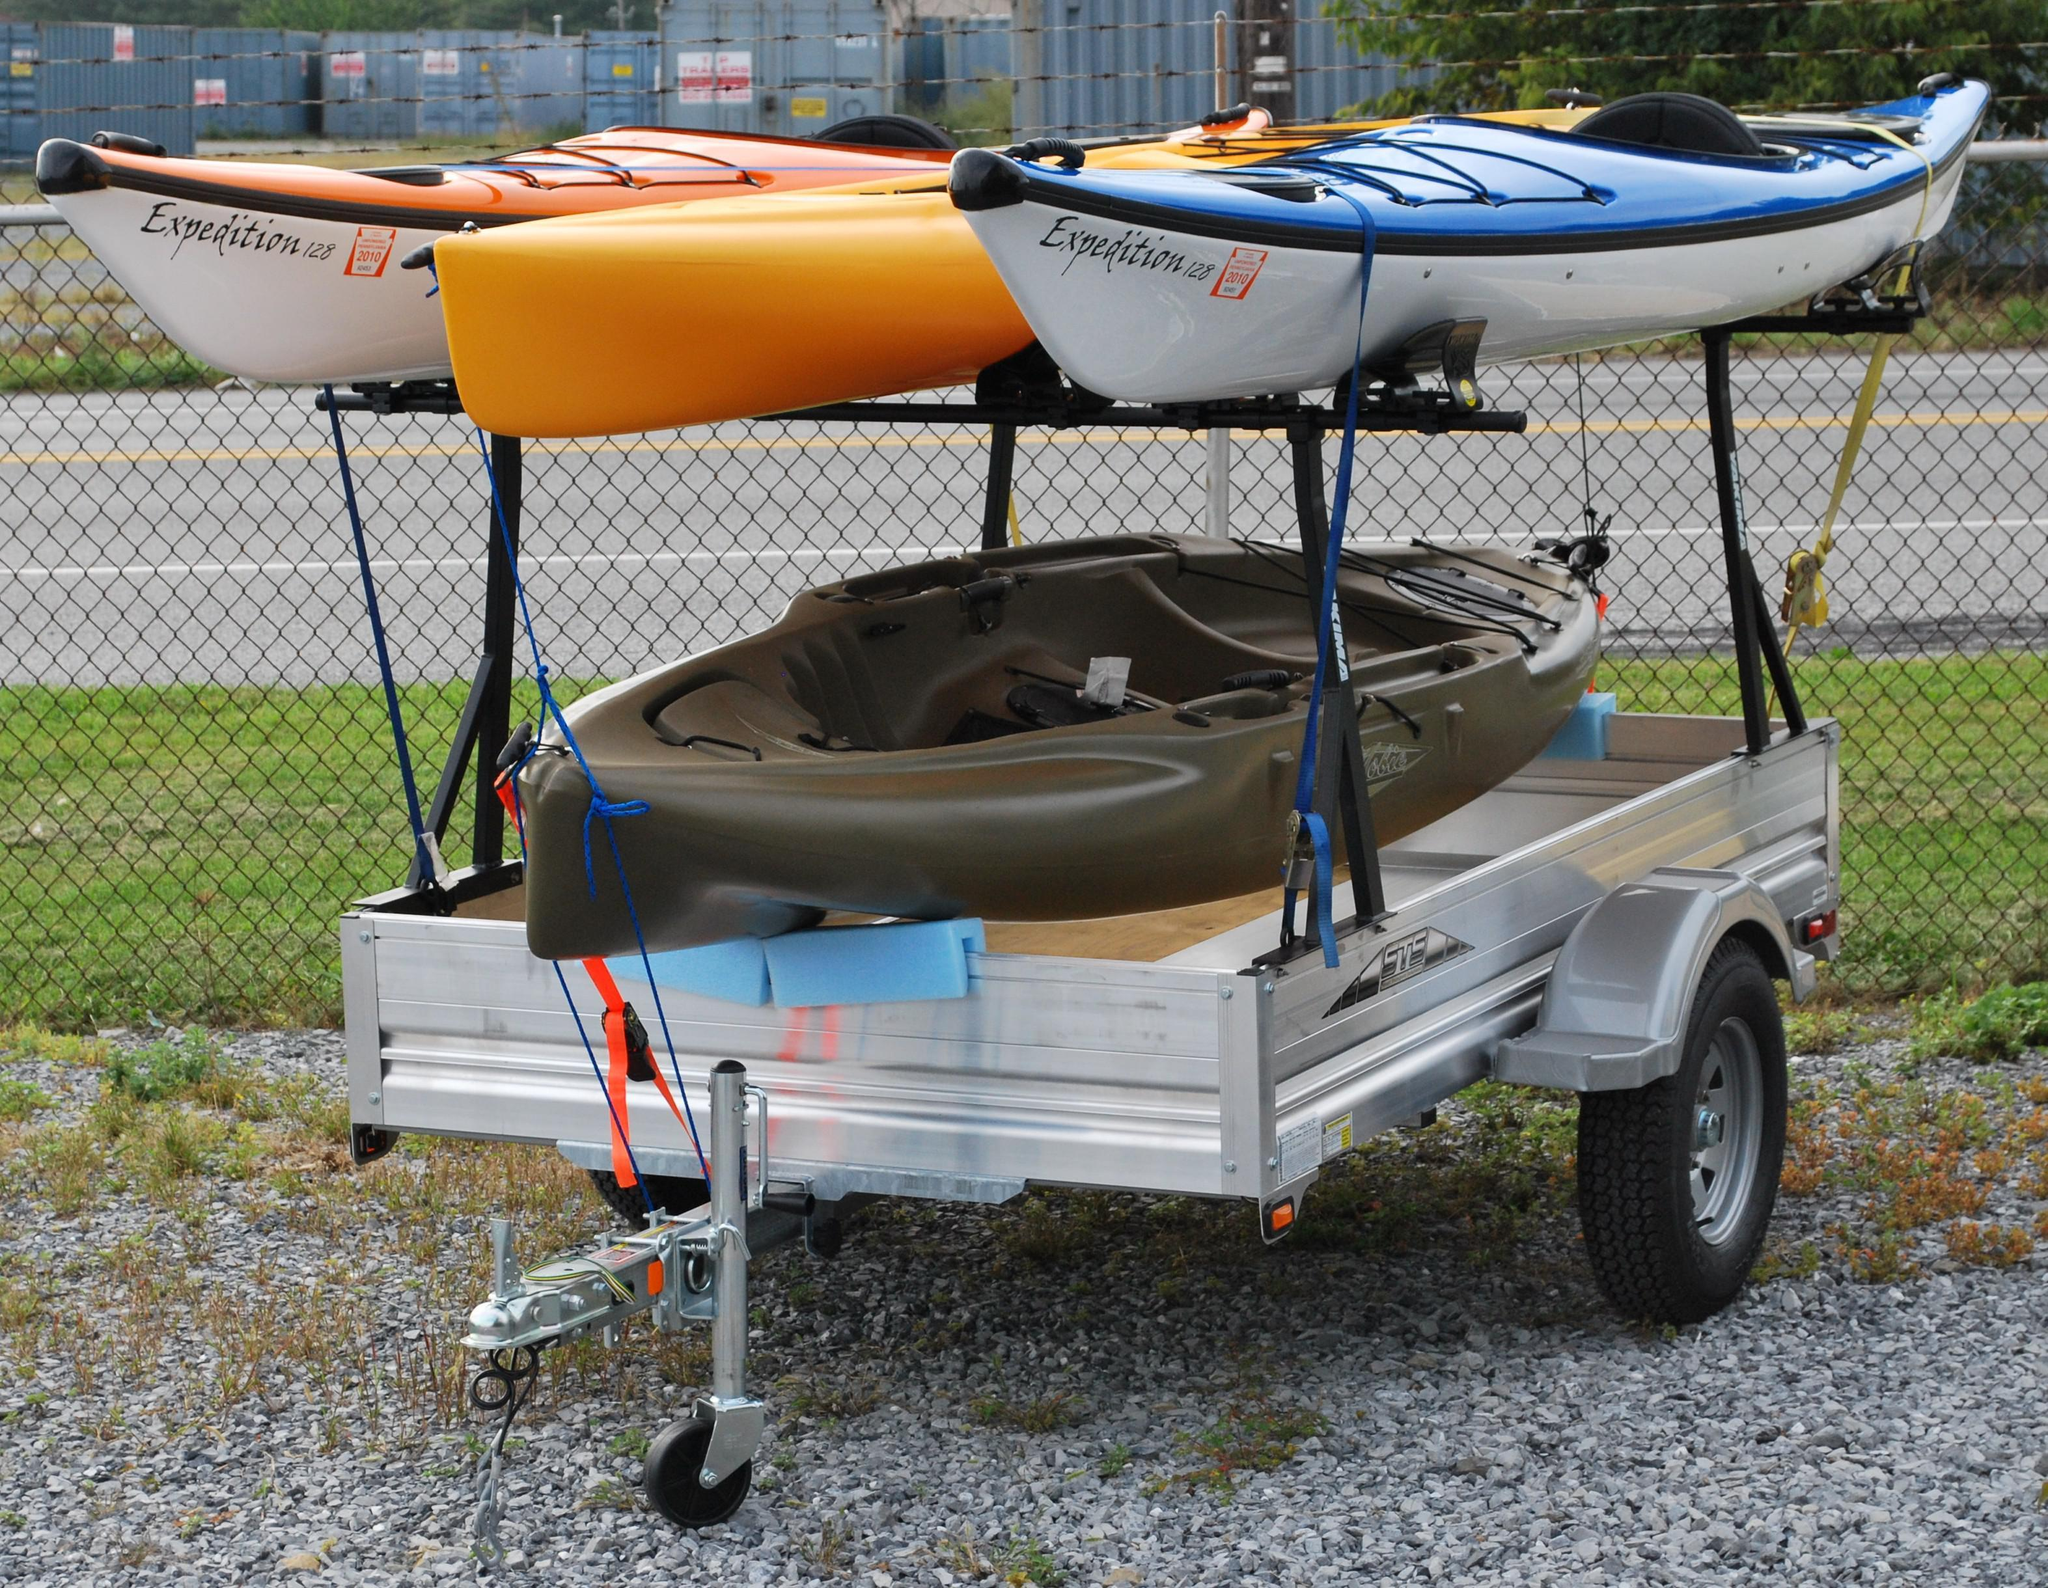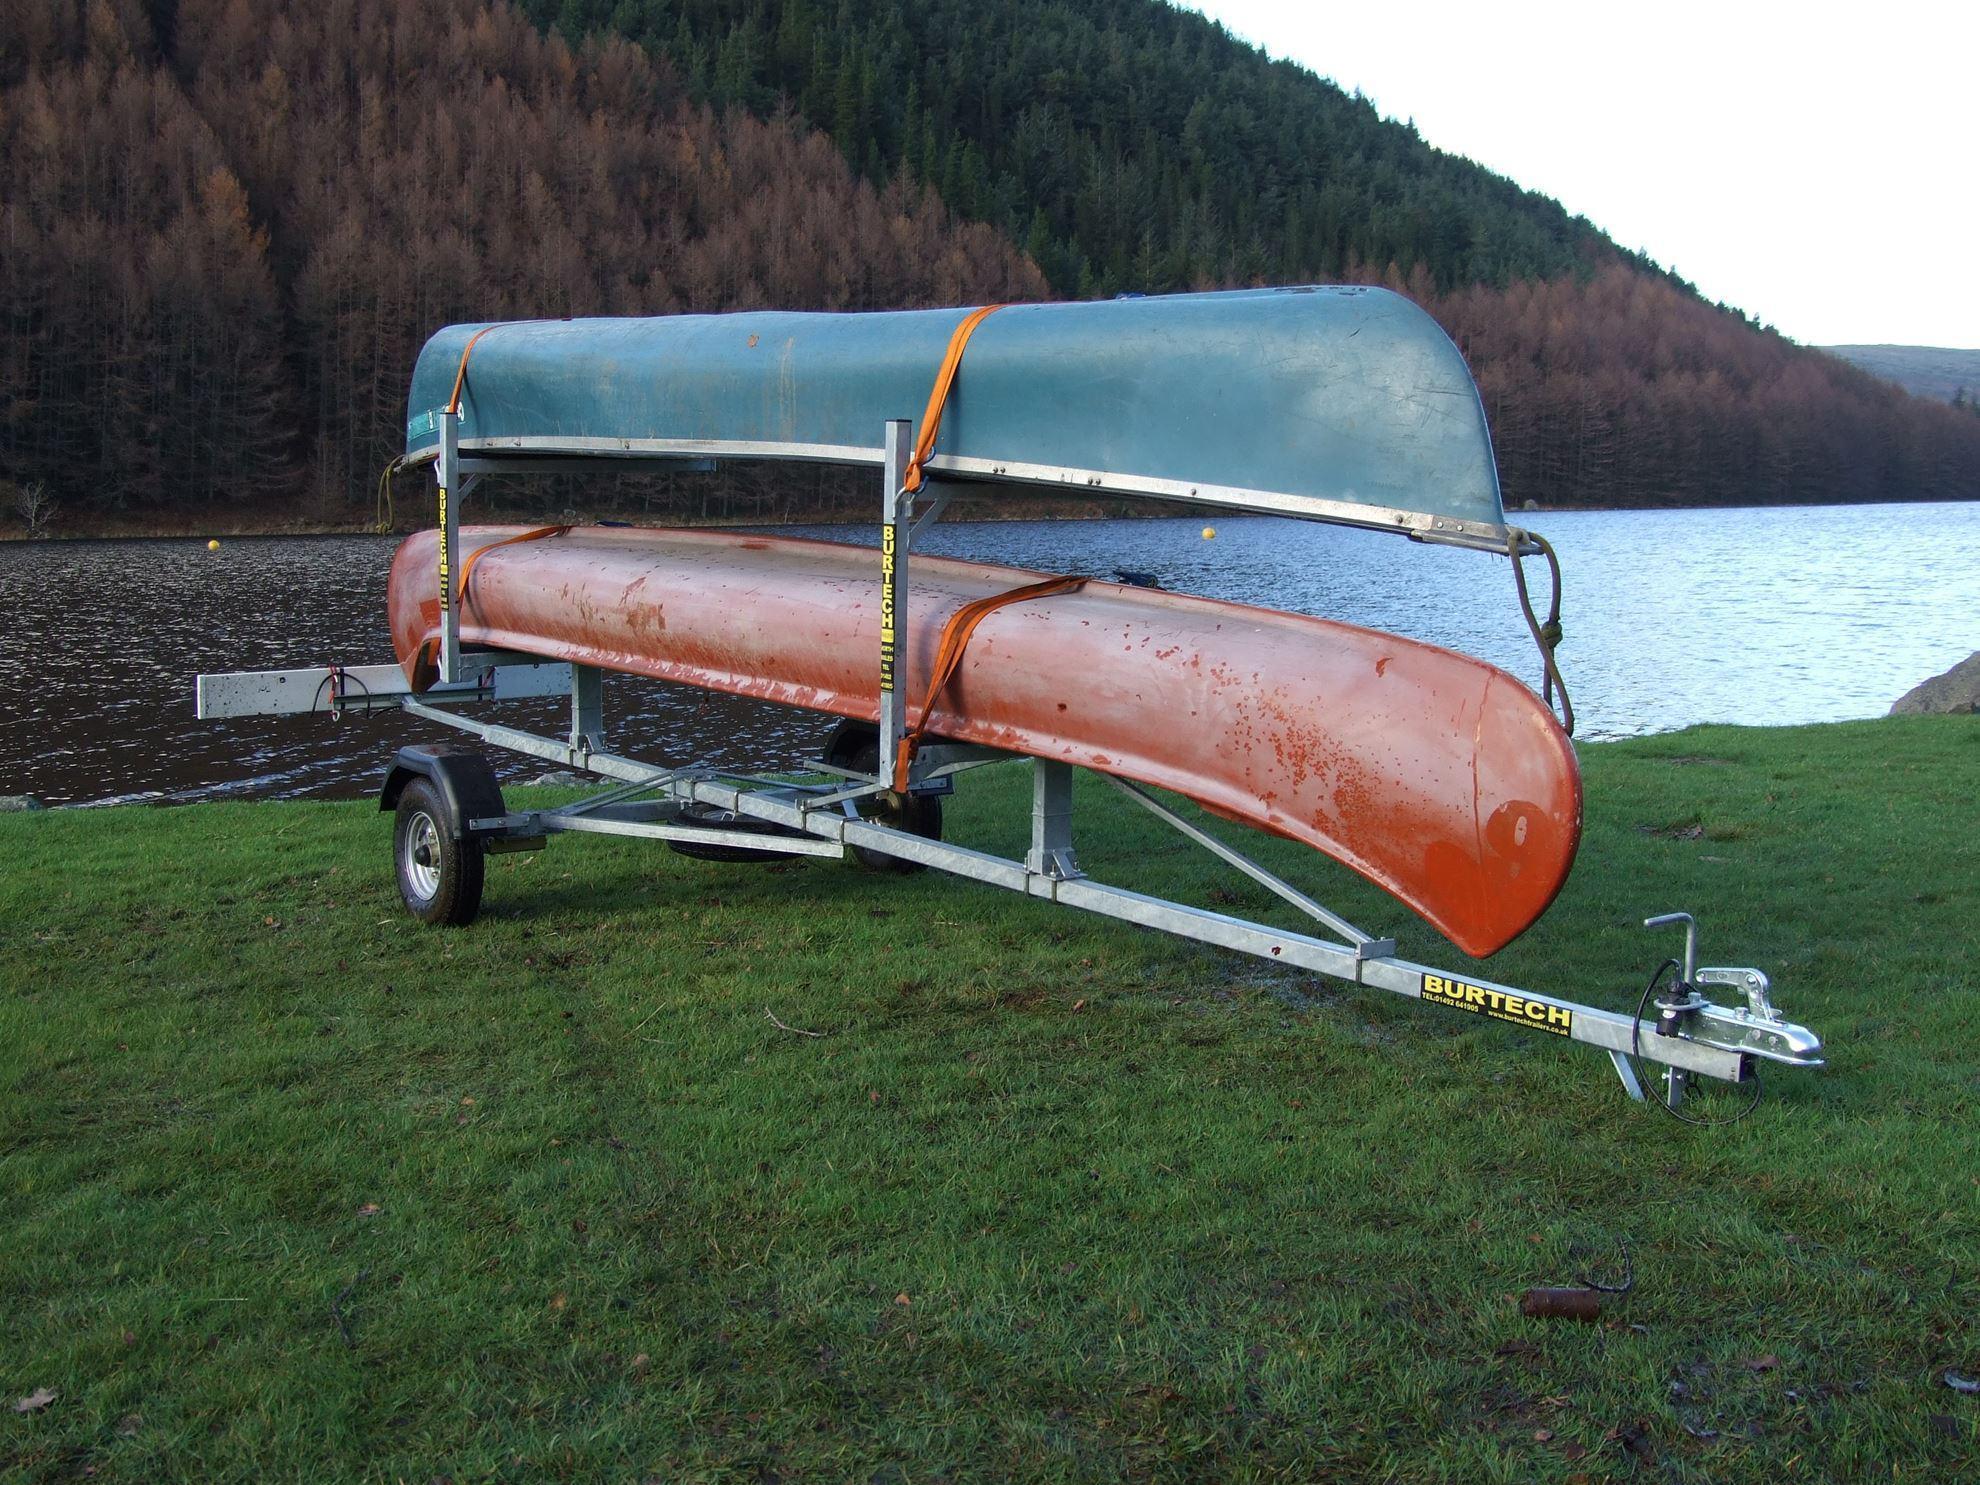The first image is the image on the left, the second image is the image on the right. Assess this claim about the two images: "One of the trailers is rectangular in shape.". Correct or not? Answer yes or no. Yes. The first image is the image on the left, the second image is the image on the right. Examine the images to the left and right. Is the description "An image shows an unattached trailer loaded with only two canoes." accurate? Answer yes or no. Yes. 